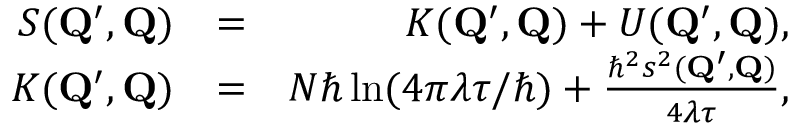<formula> <loc_0><loc_0><loc_500><loc_500>\begin{array} { r l r } { S ( Q ^ { \prime } , Q ) } & { = } & { K ( Q ^ { \prime } , Q ) + U ( Q ^ { \prime } , Q ) , } \\ { K ( Q ^ { \prime } , Q ) } & { = } & { N \hbar { \ln } ( 4 \pi \lambda \tau / \hbar { ) } + \frac { \hbar { ^ } { 2 } s ^ { 2 } ( Q ^ { \prime } , Q ) } { 4 \lambda \tau } , } \end{array}</formula> 